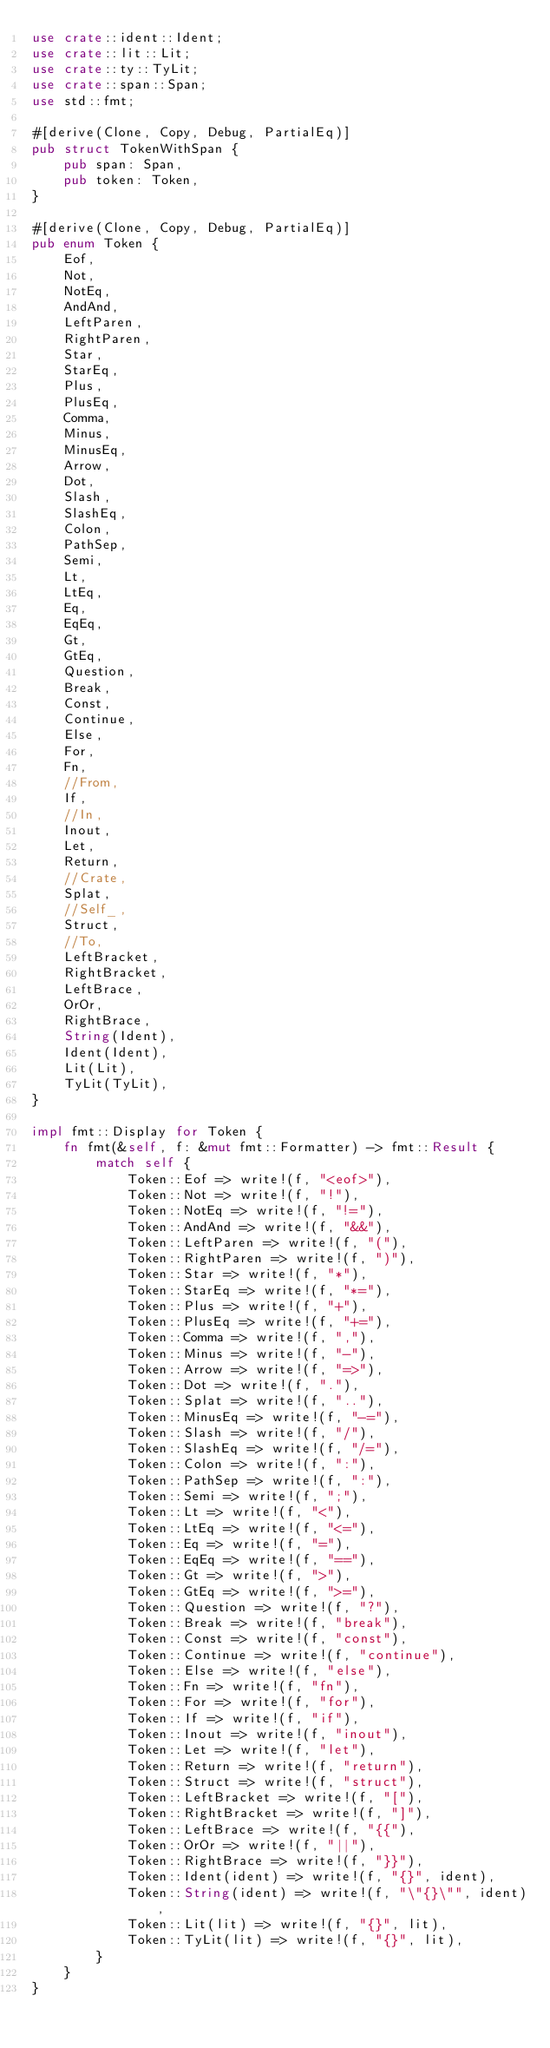Convert code to text. <code><loc_0><loc_0><loc_500><loc_500><_Rust_>use crate::ident::Ident;
use crate::lit::Lit;
use crate::ty::TyLit;
use crate::span::Span;
use std::fmt;

#[derive(Clone, Copy, Debug, PartialEq)]
pub struct TokenWithSpan {
    pub span: Span,
    pub token: Token,
}

#[derive(Clone, Copy, Debug, PartialEq)]
pub enum Token {
    Eof,
    Not,
    NotEq,
    AndAnd,
    LeftParen,
    RightParen,
    Star,
    StarEq,
    Plus,
    PlusEq,
    Comma,
    Minus,
    MinusEq,
    Arrow,
    Dot,
    Slash,
    SlashEq,
    Colon,
    PathSep,
    Semi,
    Lt,
    LtEq,
    Eq,
    EqEq,
    Gt,
    GtEq,
    Question,
    Break,
    Const,
    Continue,
    Else,
    For,
    Fn,
    //From,
    If,
    //In,
    Inout,
    Let,
    Return,
    //Crate,
    Splat,
    //Self_,
    Struct,
    //To,
    LeftBracket,
    RightBracket,
    LeftBrace,
    OrOr,
    RightBrace,
    String(Ident),
    Ident(Ident),
    Lit(Lit),
    TyLit(TyLit),
}

impl fmt::Display for Token {
    fn fmt(&self, f: &mut fmt::Formatter) -> fmt::Result {
        match self {
            Token::Eof => write!(f, "<eof>"),
            Token::Not => write!(f, "!"),
            Token::NotEq => write!(f, "!="),
            Token::AndAnd => write!(f, "&&"),
            Token::LeftParen => write!(f, "("),
            Token::RightParen => write!(f, ")"),
            Token::Star => write!(f, "*"),
            Token::StarEq => write!(f, "*="),
            Token::Plus => write!(f, "+"),
            Token::PlusEq => write!(f, "+="),
            Token::Comma => write!(f, ","),
            Token::Minus => write!(f, "-"),
            Token::Arrow => write!(f, "=>"),
            Token::Dot => write!(f, "."),
            Token::Splat => write!(f, ".."),
            Token::MinusEq => write!(f, "-="),
            Token::Slash => write!(f, "/"),
            Token::SlashEq => write!(f, "/="),
            Token::Colon => write!(f, ":"),
            Token::PathSep => write!(f, ":"),
            Token::Semi => write!(f, ";"),
            Token::Lt => write!(f, "<"),
            Token::LtEq => write!(f, "<="),
            Token::Eq => write!(f, "="),
            Token::EqEq => write!(f, "=="),
            Token::Gt => write!(f, ">"),
            Token::GtEq => write!(f, ">="),
            Token::Question => write!(f, "?"),
            Token::Break => write!(f, "break"),
            Token::Const => write!(f, "const"),
            Token::Continue => write!(f, "continue"),
            Token::Else => write!(f, "else"),
            Token::Fn => write!(f, "fn"),
            Token::For => write!(f, "for"),
            Token::If => write!(f, "if"),
            Token::Inout => write!(f, "inout"),
            Token::Let => write!(f, "let"),
            Token::Return => write!(f, "return"),
            Token::Struct => write!(f, "struct"),
            Token::LeftBracket => write!(f, "["),
            Token::RightBracket => write!(f, "]"),
            Token::LeftBrace => write!(f, "{{"),
            Token::OrOr => write!(f, "||"),
            Token::RightBrace => write!(f, "}}"),
            Token::Ident(ident) => write!(f, "{}", ident),
            Token::String(ident) => write!(f, "\"{}\"", ident),
            Token::Lit(lit) => write!(f, "{}", lit),
            Token::TyLit(lit) => write!(f, "{}", lit),
        }
    }
}
</code> 